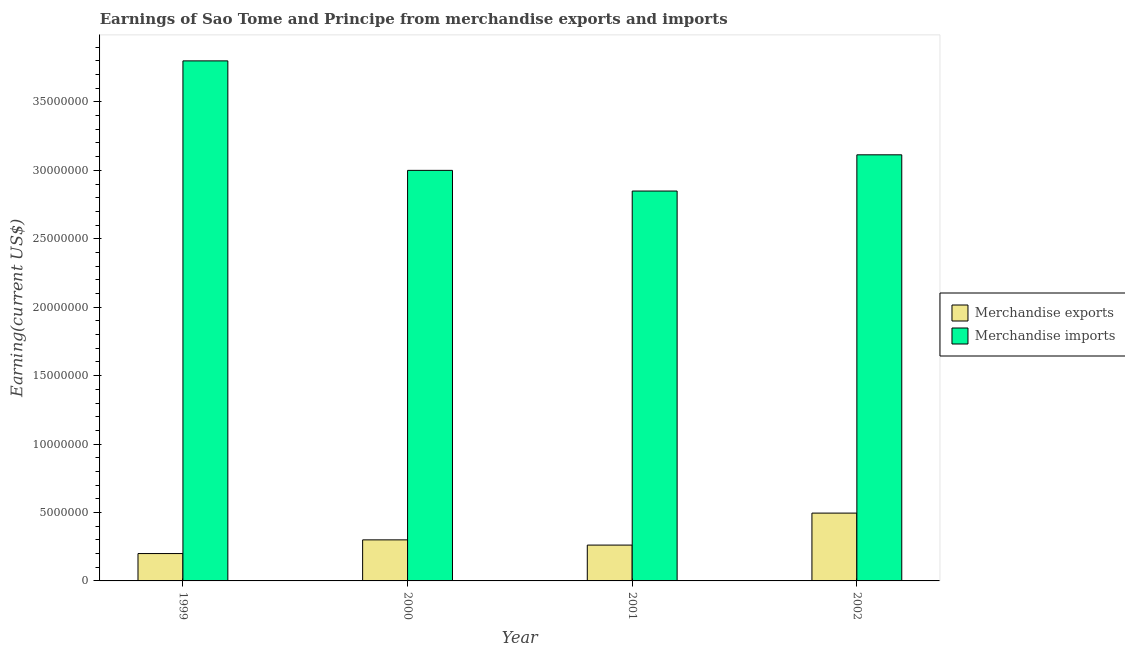Are the number of bars on each tick of the X-axis equal?
Provide a short and direct response. Yes. How many bars are there on the 2nd tick from the left?
Your response must be concise. 2. What is the label of the 4th group of bars from the left?
Provide a succinct answer. 2002. What is the earnings from merchandise imports in 2001?
Offer a terse response. 2.85e+07. Across all years, what is the maximum earnings from merchandise exports?
Your response must be concise. 4.96e+06. Across all years, what is the minimum earnings from merchandise exports?
Your answer should be compact. 2.00e+06. What is the total earnings from merchandise exports in the graph?
Ensure brevity in your answer.  1.26e+07. What is the difference between the earnings from merchandise imports in 2001 and that in 2002?
Keep it short and to the point. -2.65e+06. What is the difference between the earnings from merchandise imports in 2001 and the earnings from merchandise exports in 2002?
Make the answer very short. -2.65e+06. What is the average earnings from merchandise exports per year?
Keep it short and to the point. 3.14e+06. In the year 2000, what is the difference between the earnings from merchandise exports and earnings from merchandise imports?
Provide a succinct answer. 0. What is the ratio of the earnings from merchandise exports in 2001 to that in 2002?
Your answer should be compact. 0.53. Is the earnings from merchandise imports in 1999 less than that in 2001?
Your response must be concise. No. Is the difference between the earnings from merchandise exports in 1999 and 2000 greater than the difference between the earnings from merchandise imports in 1999 and 2000?
Offer a terse response. No. What is the difference between the highest and the second highest earnings from merchandise imports?
Offer a very short reply. 6.86e+06. What is the difference between the highest and the lowest earnings from merchandise imports?
Provide a short and direct response. 9.51e+06. In how many years, is the earnings from merchandise exports greater than the average earnings from merchandise exports taken over all years?
Your answer should be compact. 1. What does the 2nd bar from the left in 2000 represents?
Keep it short and to the point. Merchandise imports. What does the 2nd bar from the right in 2001 represents?
Provide a short and direct response. Merchandise exports. How many bars are there?
Keep it short and to the point. 8. How many years are there in the graph?
Provide a succinct answer. 4. What is the difference between two consecutive major ticks on the Y-axis?
Keep it short and to the point. 5.00e+06. Are the values on the major ticks of Y-axis written in scientific E-notation?
Offer a very short reply. No. Does the graph contain any zero values?
Your answer should be very brief. No. Does the graph contain grids?
Your answer should be compact. No. Where does the legend appear in the graph?
Provide a succinct answer. Center right. How many legend labels are there?
Your answer should be compact. 2. How are the legend labels stacked?
Ensure brevity in your answer.  Vertical. What is the title of the graph?
Give a very brief answer. Earnings of Sao Tome and Principe from merchandise exports and imports. Does "Female entrants" appear as one of the legend labels in the graph?
Give a very brief answer. No. What is the label or title of the X-axis?
Offer a very short reply. Year. What is the label or title of the Y-axis?
Provide a short and direct response. Earning(current US$). What is the Earning(current US$) in Merchandise imports in 1999?
Your answer should be compact. 3.80e+07. What is the Earning(current US$) of Merchandise exports in 2000?
Offer a very short reply. 3.00e+06. What is the Earning(current US$) in Merchandise imports in 2000?
Your answer should be compact. 3.00e+07. What is the Earning(current US$) of Merchandise exports in 2001?
Ensure brevity in your answer.  2.62e+06. What is the Earning(current US$) of Merchandise imports in 2001?
Keep it short and to the point. 2.85e+07. What is the Earning(current US$) of Merchandise exports in 2002?
Make the answer very short. 4.96e+06. What is the Earning(current US$) in Merchandise imports in 2002?
Your answer should be very brief. 3.11e+07. Across all years, what is the maximum Earning(current US$) of Merchandise exports?
Your response must be concise. 4.96e+06. Across all years, what is the maximum Earning(current US$) of Merchandise imports?
Provide a short and direct response. 3.80e+07. Across all years, what is the minimum Earning(current US$) in Merchandise exports?
Offer a very short reply. 2.00e+06. Across all years, what is the minimum Earning(current US$) of Merchandise imports?
Your answer should be very brief. 2.85e+07. What is the total Earning(current US$) of Merchandise exports in the graph?
Your response must be concise. 1.26e+07. What is the total Earning(current US$) in Merchandise imports in the graph?
Offer a very short reply. 1.28e+08. What is the difference between the Earning(current US$) of Merchandise exports in 1999 and that in 2000?
Offer a very short reply. -1.00e+06. What is the difference between the Earning(current US$) of Merchandise imports in 1999 and that in 2000?
Your answer should be very brief. 8.00e+06. What is the difference between the Earning(current US$) of Merchandise exports in 1999 and that in 2001?
Ensure brevity in your answer.  -6.19e+05. What is the difference between the Earning(current US$) of Merchandise imports in 1999 and that in 2001?
Your answer should be compact. 9.51e+06. What is the difference between the Earning(current US$) of Merchandise exports in 1999 and that in 2002?
Keep it short and to the point. -2.96e+06. What is the difference between the Earning(current US$) in Merchandise imports in 1999 and that in 2002?
Provide a succinct answer. 6.86e+06. What is the difference between the Earning(current US$) of Merchandise exports in 2000 and that in 2001?
Provide a short and direct response. 3.81e+05. What is the difference between the Earning(current US$) in Merchandise imports in 2000 and that in 2001?
Your answer should be very brief. 1.51e+06. What is the difference between the Earning(current US$) in Merchandise exports in 2000 and that in 2002?
Offer a terse response. -1.96e+06. What is the difference between the Earning(current US$) in Merchandise imports in 2000 and that in 2002?
Provide a short and direct response. -1.14e+06. What is the difference between the Earning(current US$) of Merchandise exports in 2001 and that in 2002?
Offer a very short reply. -2.34e+06. What is the difference between the Earning(current US$) of Merchandise imports in 2001 and that in 2002?
Keep it short and to the point. -2.65e+06. What is the difference between the Earning(current US$) of Merchandise exports in 1999 and the Earning(current US$) of Merchandise imports in 2000?
Your answer should be very brief. -2.80e+07. What is the difference between the Earning(current US$) of Merchandise exports in 1999 and the Earning(current US$) of Merchandise imports in 2001?
Provide a short and direct response. -2.65e+07. What is the difference between the Earning(current US$) of Merchandise exports in 1999 and the Earning(current US$) of Merchandise imports in 2002?
Your response must be concise. -2.91e+07. What is the difference between the Earning(current US$) in Merchandise exports in 2000 and the Earning(current US$) in Merchandise imports in 2001?
Provide a succinct answer. -2.55e+07. What is the difference between the Earning(current US$) in Merchandise exports in 2000 and the Earning(current US$) in Merchandise imports in 2002?
Give a very brief answer. -2.81e+07. What is the difference between the Earning(current US$) in Merchandise exports in 2001 and the Earning(current US$) in Merchandise imports in 2002?
Your answer should be compact. -2.85e+07. What is the average Earning(current US$) in Merchandise exports per year?
Make the answer very short. 3.14e+06. What is the average Earning(current US$) in Merchandise imports per year?
Offer a very short reply. 3.19e+07. In the year 1999, what is the difference between the Earning(current US$) in Merchandise exports and Earning(current US$) in Merchandise imports?
Your response must be concise. -3.60e+07. In the year 2000, what is the difference between the Earning(current US$) of Merchandise exports and Earning(current US$) of Merchandise imports?
Offer a very short reply. -2.70e+07. In the year 2001, what is the difference between the Earning(current US$) of Merchandise exports and Earning(current US$) of Merchandise imports?
Provide a short and direct response. -2.59e+07. In the year 2002, what is the difference between the Earning(current US$) of Merchandise exports and Earning(current US$) of Merchandise imports?
Your answer should be very brief. -2.62e+07. What is the ratio of the Earning(current US$) in Merchandise imports in 1999 to that in 2000?
Make the answer very short. 1.27. What is the ratio of the Earning(current US$) in Merchandise exports in 1999 to that in 2001?
Provide a succinct answer. 0.76. What is the ratio of the Earning(current US$) in Merchandise imports in 1999 to that in 2001?
Offer a terse response. 1.33. What is the ratio of the Earning(current US$) in Merchandise exports in 1999 to that in 2002?
Provide a short and direct response. 0.4. What is the ratio of the Earning(current US$) in Merchandise imports in 1999 to that in 2002?
Your answer should be very brief. 1.22. What is the ratio of the Earning(current US$) of Merchandise exports in 2000 to that in 2001?
Ensure brevity in your answer.  1.15. What is the ratio of the Earning(current US$) of Merchandise imports in 2000 to that in 2001?
Give a very brief answer. 1.05. What is the ratio of the Earning(current US$) of Merchandise exports in 2000 to that in 2002?
Your answer should be very brief. 0.61. What is the ratio of the Earning(current US$) in Merchandise imports in 2000 to that in 2002?
Your answer should be compact. 0.96. What is the ratio of the Earning(current US$) of Merchandise exports in 2001 to that in 2002?
Ensure brevity in your answer.  0.53. What is the ratio of the Earning(current US$) of Merchandise imports in 2001 to that in 2002?
Your answer should be compact. 0.92. What is the difference between the highest and the second highest Earning(current US$) in Merchandise exports?
Your response must be concise. 1.96e+06. What is the difference between the highest and the second highest Earning(current US$) of Merchandise imports?
Offer a terse response. 6.86e+06. What is the difference between the highest and the lowest Earning(current US$) of Merchandise exports?
Give a very brief answer. 2.96e+06. What is the difference between the highest and the lowest Earning(current US$) of Merchandise imports?
Your answer should be very brief. 9.51e+06. 